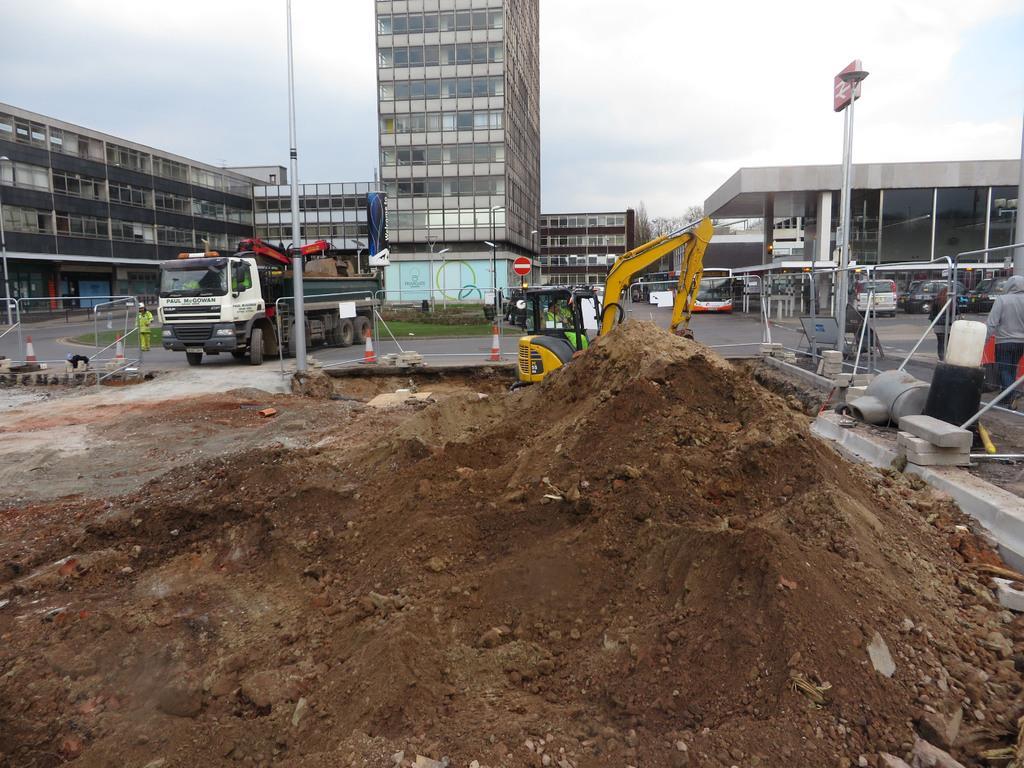Describe this image in one or two sentences. This is an outside view. At the bottom I can see the mud. At the back there is a bulldozer. In the background there are many vehicles on the road and also buildings. At the top, I can see the sky. 